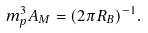<formula> <loc_0><loc_0><loc_500><loc_500>m _ { p } ^ { 3 } A _ { M } = ( 2 \pi R _ { B } ) ^ { - 1 } .</formula> 